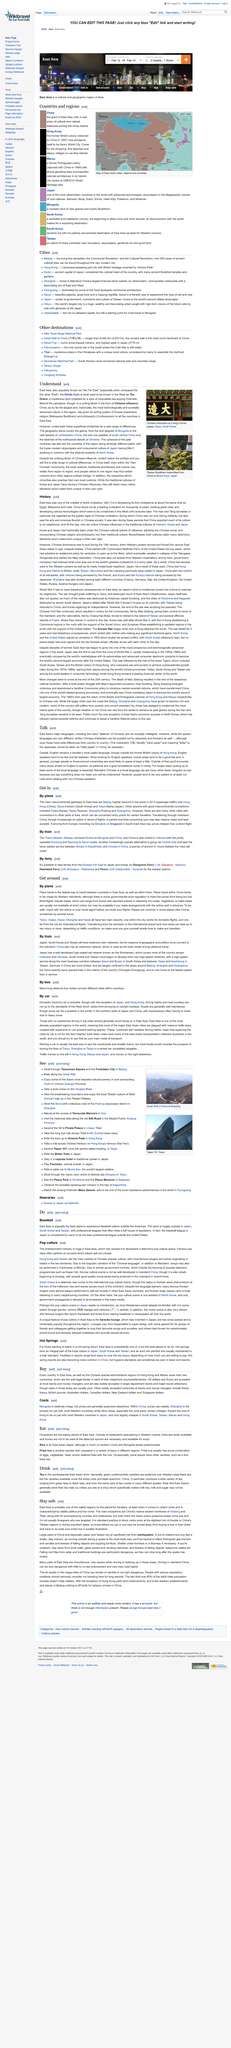Give some essential details in this illustration. East Asia, commonly referred to as the 'Far East,' is a region that is well-known for its rich culture, history, and diversity. In the Western world, East Asia was previously recognized as The Orient. China has made significant contributions to the countries in East Asia by sharing its writing system, religion, and philosophy. 